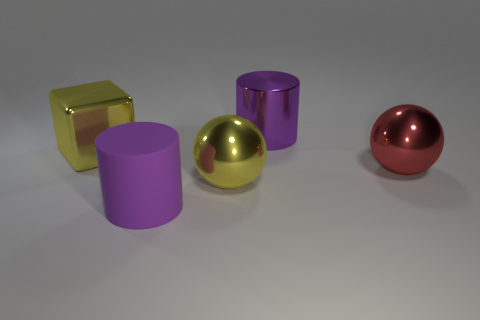Is there any other thing that is the same color as the metal cylinder?
Your answer should be compact. Yes. Are the big purple object that is behind the yellow cube and the big block made of the same material?
Provide a succinct answer. Yes. Is the number of objects that are to the right of the big metal block the same as the number of red metal things on the right side of the large red shiny thing?
Make the answer very short. No. There is a purple cylinder to the right of the large purple cylinder in front of the big red metal ball; what is its size?
Make the answer very short. Large. There is a big object that is both to the right of the large metallic cube and on the left side of the large yellow sphere; what material is it?
Keep it short and to the point. Rubber. How many other objects are the same size as the yellow cube?
Make the answer very short. 4. The large metallic cylinder is what color?
Offer a terse response. Purple. Is the color of the metallic ball that is in front of the red ball the same as the ball that is on the right side of the large purple shiny thing?
Make the answer very short. No. The yellow ball is what size?
Your answer should be compact. Large. There is a purple thing on the right side of the yellow sphere; how big is it?
Ensure brevity in your answer.  Large. 